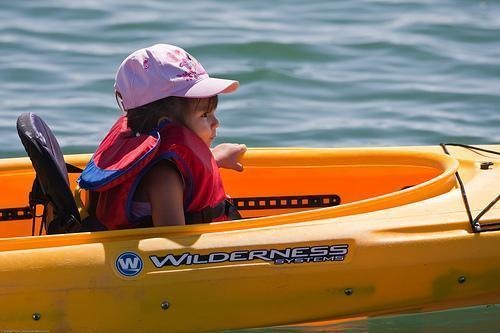How many kids are there?
Give a very brief answer. 1. 